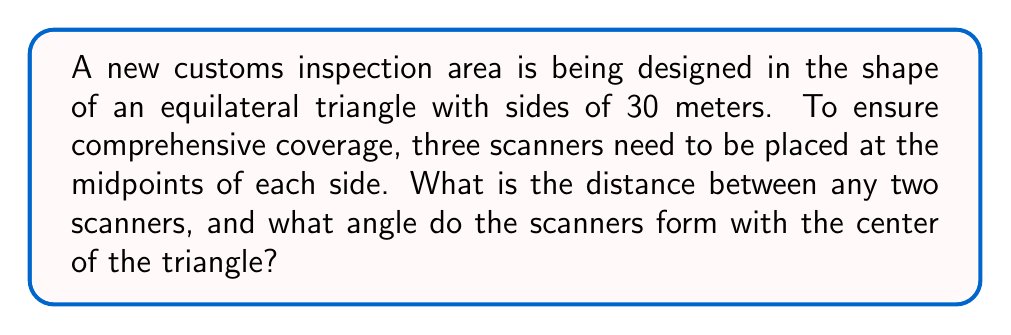Show me your answer to this math problem. Let's approach this step-by-step:

1) First, let's consider the properties of an equilateral triangle:
   - All sides are equal
   - All angles are 60°

2) Let's draw the triangle and mark the midpoints:

[asy]
unitsize(4mm);
pair A = (0,0), B = (5*sqrt(3),5), C = (10*sqrt(3),0);
pair M1 = (A+B)/2, M2 = (B+C)/2, M3 = (C+A)/2;
pair O = (A+B+C)/3;
draw(A--B--C--cycle);
dot(M1); dot(M2); dot(M3); dot(O);
label("A", A, SW);
label("B", B, N);
label("C", C, SE);
label("M1", M1, NW);
label("M2", M2, E);
label("M3", M3, S);
label("O", O, NE);
[/asy]

3) To find the distance between two scanners, we need to find the length of the line segment connecting two midpoints (e.g., M1M2).

4) In an equilateral triangle, the line segment connecting two midpoints is parallel to the opposite side and its length is half the length of that side.

5) Therefore, the distance between any two scanners is:
   $$ \text{Distance} = \frac{1}{2} \times 30 = 15 \text{ meters} $$

6) To find the angle that the scanners form with the center of the triangle, we need to consider the properties of the center of an equilateral triangle:
   - The center is located at the intersection of the three medians
   - Each median divides the opposite side into two equal parts

7) This means that the line from the center to a midpoint (scanner location) bisects the angle at the vertex.

8) Since each angle in an equilateral triangle is 60°, the angle formed by two adjacent scanners and the center is:
   $$ \text{Angle} = \frac{60°}{2} = 30° $$
Answer: 15 meters; 30° 